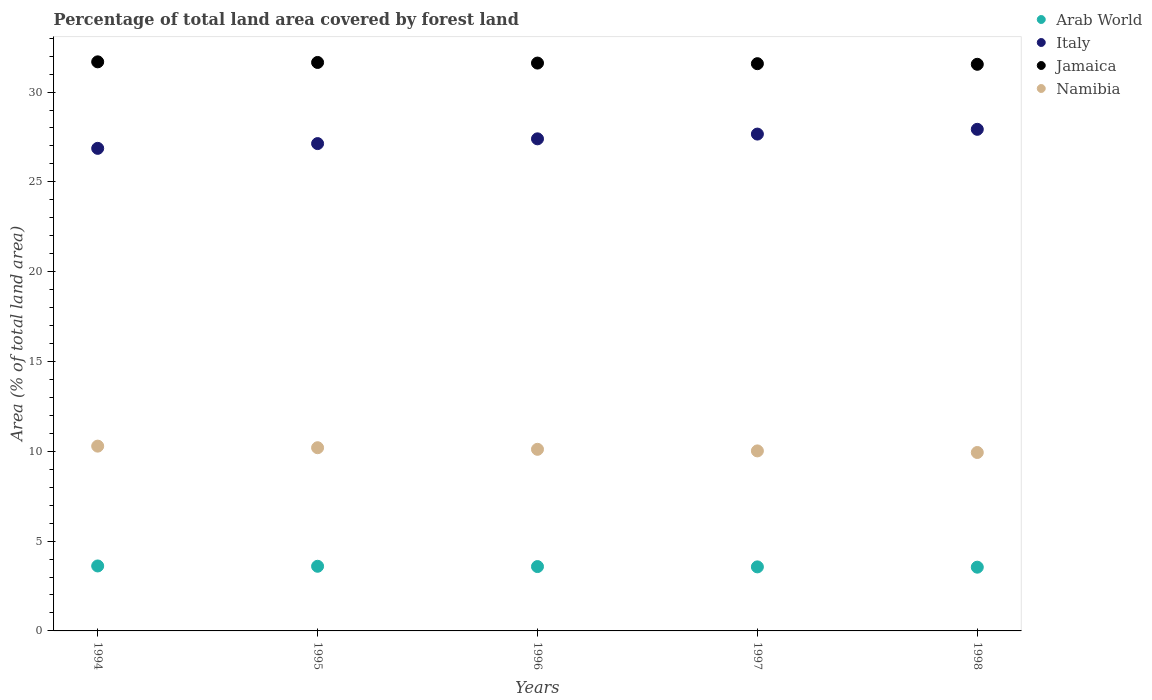How many different coloured dotlines are there?
Provide a succinct answer. 4. What is the percentage of forest land in Jamaica in 1998?
Give a very brief answer. 31.55. Across all years, what is the maximum percentage of forest land in Italy?
Provide a short and direct response. 27.93. Across all years, what is the minimum percentage of forest land in Arab World?
Your answer should be very brief. 3.55. In which year was the percentage of forest land in Italy minimum?
Your response must be concise. 1994. What is the total percentage of forest land in Arab World in the graph?
Give a very brief answer. 17.91. What is the difference between the percentage of forest land in Arab World in 1996 and that in 1998?
Provide a succinct answer. 0.03. What is the difference between the percentage of forest land in Arab World in 1994 and the percentage of forest land in Italy in 1995?
Give a very brief answer. -23.51. What is the average percentage of forest land in Namibia per year?
Provide a succinct answer. 10.11. In the year 1998, what is the difference between the percentage of forest land in Italy and percentage of forest land in Namibia?
Provide a succinct answer. 17.99. What is the ratio of the percentage of forest land in Arab World in 1995 to that in 1996?
Keep it short and to the point. 1. Is the difference between the percentage of forest land in Italy in 1994 and 1995 greater than the difference between the percentage of forest land in Namibia in 1994 and 1995?
Your response must be concise. No. What is the difference between the highest and the second highest percentage of forest land in Namibia?
Your answer should be compact. 0.09. What is the difference between the highest and the lowest percentage of forest land in Namibia?
Keep it short and to the point. 0.35. Is the sum of the percentage of forest land in Italy in 1995 and 1997 greater than the maximum percentage of forest land in Namibia across all years?
Give a very brief answer. Yes. Is the percentage of forest land in Namibia strictly greater than the percentage of forest land in Italy over the years?
Offer a very short reply. No. How many dotlines are there?
Your answer should be compact. 4. How many years are there in the graph?
Offer a terse response. 5. Does the graph contain grids?
Your answer should be compact. No. Where does the legend appear in the graph?
Make the answer very short. Top right. How many legend labels are there?
Give a very brief answer. 4. How are the legend labels stacked?
Keep it short and to the point. Vertical. What is the title of the graph?
Offer a terse response. Percentage of total land area covered by forest land. Does "Middle income" appear as one of the legend labels in the graph?
Your answer should be very brief. No. What is the label or title of the Y-axis?
Ensure brevity in your answer.  Area (% of total land area). What is the Area (% of total land area) of Arab World in 1994?
Your answer should be compact. 3.62. What is the Area (% of total land area) in Italy in 1994?
Give a very brief answer. 26.87. What is the Area (% of total land area) in Jamaica in 1994?
Provide a succinct answer. 31.68. What is the Area (% of total land area) in Namibia in 1994?
Your response must be concise. 10.29. What is the Area (% of total land area) in Arab World in 1995?
Offer a very short reply. 3.6. What is the Area (% of total land area) of Italy in 1995?
Provide a short and direct response. 27.13. What is the Area (% of total land area) in Jamaica in 1995?
Give a very brief answer. 31.65. What is the Area (% of total land area) of Namibia in 1995?
Keep it short and to the point. 10.2. What is the Area (% of total land area) of Arab World in 1996?
Your answer should be very brief. 3.58. What is the Area (% of total land area) of Italy in 1996?
Make the answer very short. 27.4. What is the Area (% of total land area) in Jamaica in 1996?
Provide a short and direct response. 31.61. What is the Area (% of total land area) of Namibia in 1996?
Your response must be concise. 10.11. What is the Area (% of total land area) in Arab World in 1997?
Make the answer very short. 3.57. What is the Area (% of total land area) of Italy in 1997?
Offer a very short reply. 27.66. What is the Area (% of total land area) of Jamaica in 1997?
Make the answer very short. 31.58. What is the Area (% of total land area) of Namibia in 1997?
Offer a very short reply. 10.02. What is the Area (% of total land area) of Arab World in 1998?
Provide a succinct answer. 3.55. What is the Area (% of total land area) in Italy in 1998?
Your answer should be very brief. 27.93. What is the Area (% of total land area) in Jamaica in 1998?
Offer a very short reply. 31.55. What is the Area (% of total land area) in Namibia in 1998?
Your response must be concise. 9.93. Across all years, what is the maximum Area (% of total land area) in Arab World?
Provide a succinct answer. 3.62. Across all years, what is the maximum Area (% of total land area) of Italy?
Your answer should be very brief. 27.93. Across all years, what is the maximum Area (% of total land area) of Jamaica?
Provide a succinct answer. 31.68. Across all years, what is the maximum Area (% of total land area) in Namibia?
Your answer should be compact. 10.29. Across all years, what is the minimum Area (% of total land area) of Arab World?
Provide a succinct answer. 3.55. Across all years, what is the minimum Area (% of total land area) of Italy?
Make the answer very short. 26.87. Across all years, what is the minimum Area (% of total land area) of Jamaica?
Keep it short and to the point. 31.55. Across all years, what is the minimum Area (% of total land area) of Namibia?
Your response must be concise. 9.93. What is the total Area (% of total land area) of Arab World in the graph?
Provide a short and direct response. 17.91. What is the total Area (% of total land area) in Italy in the graph?
Your answer should be very brief. 136.98. What is the total Area (% of total land area) of Jamaica in the graph?
Offer a terse response. 158.07. What is the total Area (% of total land area) of Namibia in the graph?
Your response must be concise. 50.55. What is the difference between the Area (% of total land area) of Arab World in 1994 and that in 1995?
Give a very brief answer. 0.02. What is the difference between the Area (% of total land area) in Italy in 1994 and that in 1995?
Provide a succinct answer. -0.26. What is the difference between the Area (% of total land area) in Jamaica in 1994 and that in 1995?
Give a very brief answer. 0.03. What is the difference between the Area (% of total land area) of Namibia in 1994 and that in 1995?
Provide a short and direct response. 0.09. What is the difference between the Area (% of total land area) of Arab World in 1994 and that in 1996?
Offer a very short reply. 0.03. What is the difference between the Area (% of total land area) in Italy in 1994 and that in 1996?
Ensure brevity in your answer.  -0.53. What is the difference between the Area (% of total land area) of Jamaica in 1994 and that in 1996?
Provide a short and direct response. 0.07. What is the difference between the Area (% of total land area) of Namibia in 1994 and that in 1996?
Provide a short and direct response. 0.18. What is the difference between the Area (% of total land area) in Arab World in 1994 and that in 1997?
Give a very brief answer. 0.05. What is the difference between the Area (% of total land area) of Italy in 1994 and that in 1997?
Your answer should be compact. -0.79. What is the difference between the Area (% of total land area) in Jamaica in 1994 and that in 1997?
Offer a very short reply. 0.1. What is the difference between the Area (% of total land area) in Namibia in 1994 and that in 1997?
Give a very brief answer. 0.27. What is the difference between the Area (% of total land area) of Arab World in 1994 and that in 1998?
Keep it short and to the point. 0.07. What is the difference between the Area (% of total land area) in Italy in 1994 and that in 1998?
Offer a very short reply. -1.06. What is the difference between the Area (% of total land area) of Jamaica in 1994 and that in 1998?
Give a very brief answer. 0.14. What is the difference between the Area (% of total land area) in Namibia in 1994 and that in 1998?
Make the answer very short. 0.35. What is the difference between the Area (% of total land area) in Arab World in 1995 and that in 1996?
Provide a short and direct response. 0.02. What is the difference between the Area (% of total land area) of Italy in 1995 and that in 1996?
Give a very brief answer. -0.26. What is the difference between the Area (% of total land area) of Jamaica in 1995 and that in 1996?
Provide a succinct answer. 0.03. What is the difference between the Area (% of total land area) in Namibia in 1995 and that in 1996?
Make the answer very short. 0.09. What is the difference between the Area (% of total land area) of Arab World in 1995 and that in 1997?
Ensure brevity in your answer.  0.03. What is the difference between the Area (% of total land area) in Italy in 1995 and that in 1997?
Your response must be concise. -0.53. What is the difference between the Area (% of total land area) of Jamaica in 1995 and that in 1997?
Ensure brevity in your answer.  0.07. What is the difference between the Area (% of total land area) of Namibia in 1995 and that in 1997?
Offer a very short reply. 0.18. What is the difference between the Area (% of total land area) of Arab World in 1995 and that in 1998?
Offer a very short reply. 0.05. What is the difference between the Area (% of total land area) of Italy in 1995 and that in 1998?
Your response must be concise. -0.79. What is the difference between the Area (% of total land area) in Jamaica in 1995 and that in 1998?
Your response must be concise. 0.1. What is the difference between the Area (% of total land area) in Namibia in 1995 and that in 1998?
Your response must be concise. 0.27. What is the difference between the Area (% of total land area) in Arab World in 1996 and that in 1997?
Your answer should be very brief. 0.02. What is the difference between the Area (% of total land area) of Italy in 1996 and that in 1997?
Make the answer very short. -0.26. What is the difference between the Area (% of total land area) in Jamaica in 1996 and that in 1997?
Your response must be concise. 0.03. What is the difference between the Area (% of total land area) of Namibia in 1996 and that in 1997?
Offer a very short reply. 0.09. What is the difference between the Area (% of total land area) in Arab World in 1996 and that in 1998?
Provide a short and direct response. 0.03. What is the difference between the Area (% of total land area) in Italy in 1996 and that in 1998?
Your response must be concise. -0.53. What is the difference between the Area (% of total land area) in Jamaica in 1996 and that in 1998?
Give a very brief answer. 0.07. What is the difference between the Area (% of total land area) in Namibia in 1996 and that in 1998?
Ensure brevity in your answer.  0.18. What is the difference between the Area (% of total land area) of Arab World in 1997 and that in 1998?
Offer a terse response. 0.02. What is the difference between the Area (% of total land area) of Italy in 1997 and that in 1998?
Provide a succinct answer. -0.26. What is the difference between the Area (% of total land area) of Jamaica in 1997 and that in 1998?
Give a very brief answer. 0.03. What is the difference between the Area (% of total land area) in Namibia in 1997 and that in 1998?
Your answer should be compact. 0.09. What is the difference between the Area (% of total land area) of Arab World in 1994 and the Area (% of total land area) of Italy in 1995?
Provide a short and direct response. -23.51. What is the difference between the Area (% of total land area) in Arab World in 1994 and the Area (% of total land area) in Jamaica in 1995?
Your answer should be very brief. -28.03. What is the difference between the Area (% of total land area) in Arab World in 1994 and the Area (% of total land area) in Namibia in 1995?
Keep it short and to the point. -6.58. What is the difference between the Area (% of total land area) of Italy in 1994 and the Area (% of total land area) of Jamaica in 1995?
Provide a short and direct response. -4.78. What is the difference between the Area (% of total land area) in Italy in 1994 and the Area (% of total land area) in Namibia in 1995?
Make the answer very short. 16.67. What is the difference between the Area (% of total land area) in Jamaica in 1994 and the Area (% of total land area) in Namibia in 1995?
Provide a short and direct response. 21.48. What is the difference between the Area (% of total land area) in Arab World in 1994 and the Area (% of total land area) in Italy in 1996?
Provide a short and direct response. -23.78. What is the difference between the Area (% of total land area) in Arab World in 1994 and the Area (% of total land area) in Jamaica in 1996?
Give a very brief answer. -28. What is the difference between the Area (% of total land area) of Arab World in 1994 and the Area (% of total land area) of Namibia in 1996?
Provide a short and direct response. -6.49. What is the difference between the Area (% of total land area) in Italy in 1994 and the Area (% of total land area) in Jamaica in 1996?
Your response must be concise. -4.75. What is the difference between the Area (% of total land area) of Italy in 1994 and the Area (% of total land area) of Namibia in 1996?
Provide a short and direct response. 16.76. What is the difference between the Area (% of total land area) of Jamaica in 1994 and the Area (% of total land area) of Namibia in 1996?
Offer a very short reply. 21.57. What is the difference between the Area (% of total land area) of Arab World in 1994 and the Area (% of total land area) of Italy in 1997?
Offer a very short reply. -24.04. What is the difference between the Area (% of total land area) in Arab World in 1994 and the Area (% of total land area) in Jamaica in 1997?
Offer a terse response. -27.96. What is the difference between the Area (% of total land area) in Arab World in 1994 and the Area (% of total land area) in Namibia in 1997?
Provide a short and direct response. -6.41. What is the difference between the Area (% of total land area) of Italy in 1994 and the Area (% of total land area) of Jamaica in 1997?
Provide a succinct answer. -4.71. What is the difference between the Area (% of total land area) of Italy in 1994 and the Area (% of total land area) of Namibia in 1997?
Keep it short and to the point. 16.84. What is the difference between the Area (% of total land area) in Jamaica in 1994 and the Area (% of total land area) in Namibia in 1997?
Provide a succinct answer. 21.66. What is the difference between the Area (% of total land area) of Arab World in 1994 and the Area (% of total land area) of Italy in 1998?
Make the answer very short. -24.31. What is the difference between the Area (% of total land area) of Arab World in 1994 and the Area (% of total land area) of Jamaica in 1998?
Make the answer very short. -27.93. What is the difference between the Area (% of total land area) of Arab World in 1994 and the Area (% of total land area) of Namibia in 1998?
Ensure brevity in your answer.  -6.32. What is the difference between the Area (% of total land area) of Italy in 1994 and the Area (% of total land area) of Jamaica in 1998?
Give a very brief answer. -4.68. What is the difference between the Area (% of total land area) of Italy in 1994 and the Area (% of total land area) of Namibia in 1998?
Make the answer very short. 16.93. What is the difference between the Area (% of total land area) of Jamaica in 1994 and the Area (% of total land area) of Namibia in 1998?
Provide a succinct answer. 21.75. What is the difference between the Area (% of total land area) of Arab World in 1995 and the Area (% of total land area) of Italy in 1996?
Offer a very short reply. -23.8. What is the difference between the Area (% of total land area) of Arab World in 1995 and the Area (% of total land area) of Jamaica in 1996?
Provide a short and direct response. -28.01. What is the difference between the Area (% of total land area) in Arab World in 1995 and the Area (% of total land area) in Namibia in 1996?
Your response must be concise. -6.51. What is the difference between the Area (% of total land area) of Italy in 1995 and the Area (% of total land area) of Jamaica in 1996?
Keep it short and to the point. -4.48. What is the difference between the Area (% of total land area) in Italy in 1995 and the Area (% of total land area) in Namibia in 1996?
Ensure brevity in your answer.  17.02. What is the difference between the Area (% of total land area) of Jamaica in 1995 and the Area (% of total land area) of Namibia in 1996?
Your answer should be very brief. 21.54. What is the difference between the Area (% of total land area) of Arab World in 1995 and the Area (% of total land area) of Italy in 1997?
Your response must be concise. -24.06. What is the difference between the Area (% of total land area) of Arab World in 1995 and the Area (% of total land area) of Jamaica in 1997?
Provide a short and direct response. -27.98. What is the difference between the Area (% of total land area) in Arab World in 1995 and the Area (% of total land area) in Namibia in 1997?
Your answer should be very brief. -6.42. What is the difference between the Area (% of total land area) in Italy in 1995 and the Area (% of total land area) in Jamaica in 1997?
Offer a terse response. -4.45. What is the difference between the Area (% of total land area) in Italy in 1995 and the Area (% of total land area) in Namibia in 1997?
Your answer should be very brief. 17.11. What is the difference between the Area (% of total land area) of Jamaica in 1995 and the Area (% of total land area) of Namibia in 1997?
Your response must be concise. 21.63. What is the difference between the Area (% of total land area) of Arab World in 1995 and the Area (% of total land area) of Italy in 1998?
Offer a very short reply. -24.33. What is the difference between the Area (% of total land area) of Arab World in 1995 and the Area (% of total land area) of Jamaica in 1998?
Ensure brevity in your answer.  -27.95. What is the difference between the Area (% of total land area) in Arab World in 1995 and the Area (% of total land area) in Namibia in 1998?
Ensure brevity in your answer.  -6.33. What is the difference between the Area (% of total land area) of Italy in 1995 and the Area (% of total land area) of Jamaica in 1998?
Ensure brevity in your answer.  -4.41. What is the difference between the Area (% of total land area) of Italy in 1995 and the Area (% of total land area) of Namibia in 1998?
Make the answer very short. 17.2. What is the difference between the Area (% of total land area) of Jamaica in 1995 and the Area (% of total land area) of Namibia in 1998?
Give a very brief answer. 21.71. What is the difference between the Area (% of total land area) of Arab World in 1996 and the Area (% of total land area) of Italy in 1997?
Offer a very short reply. -24.08. What is the difference between the Area (% of total land area) in Arab World in 1996 and the Area (% of total land area) in Jamaica in 1997?
Make the answer very short. -28. What is the difference between the Area (% of total land area) of Arab World in 1996 and the Area (% of total land area) of Namibia in 1997?
Make the answer very short. -6.44. What is the difference between the Area (% of total land area) in Italy in 1996 and the Area (% of total land area) in Jamaica in 1997?
Provide a succinct answer. -4.18. What is the difference between the Area (% of total land area) in Italy in 1996 and the Area (% of total land area) in Namibia in 1997?
Make the answer very short. 17.37. What is the difference between the Area (% of total land area) in Jamaica in 1996 and the Area (% of total land area) in Namibia in 1997?
Offer a terse response. 21.59. What is the difference between the Area (% of total land area) of Arab World in 1996 and the Area (% of total land area) of Italy in 1998?
Give a very brief answer. -24.34. What is the difference between the Area (% of total land area) in Arab World in 1996 and the Area (% of total land area) in Jamaica in 1998?
Your answer should be compact. -27.96. What is the difference between the Area (% of total land area) in Arab World in 1996 and the Area (% of total land area) in Namibia in 1998?
Offer a very short reply. -6.35. What is the difference between the Area (% of total land area) in Italy in 1996 and the Area (% of total land area) in Jamaica in 1998?
Make the answer very short. -4.15. What is the difference between the Area (% of total land area) in Italy in 1996 and the Area (% of total land area) in Namibia in 1998?
Provide a succinct answer. 17.46. What is the difference between the Area (% of total land area) of Jamaica in 1996 and the Area (% of total land area) of Namibia in 1998?
Offer a very short reply. 21.68. What is the difference between the Area (% of total land area) in Arab World in 1997 and the Area (% of total land area) in Italy in 1998?
Your answer should be compact. -24.36. What is the difference between the Area (% of total land area) in Arab World in 1997 and the Area (% of total land area) in Jamaica in 1998?
Your answer should be very brief. -27.98. What is the difference between the Area (% of total land area) in Arab World in 1997 and the Area (% of total land area) in Namibia in 1998?
Your answer should be compact. -6.37. What is the difference between the Area (% of total land area) of Italy in 1997 and the Area (% of total land area) of Jamaica in 1998?
Provide a succinct answer. -3.88. What is the difference between the Area (% of total land area) in Italy in 1997 and the Area (% of total land area) in Namibia in 1998?
Offer a very short reply. 17.73. What is the difference between the Area (% of total land area) of Jamaica in 1997 and the Area (% of total land area) of Namibia in 1998?
Your answer should be compact. 21.65. What is the average Area (% of total land area) of Arab World per year?
Provide a succinct answer. 3.58. What is the average Area (% of total land area) of Italy per year?
Give a very brief answer. 27.4. What is the average Area (% of total land area) of Jamaica per year?
Make the answer very short. 31.61. What is the average Area (% of total land area) of Namibia per year?
Your answer should be very brief. 10.11. In the year 1994, what is the difference between the Area (% of total land area) of Arab World and Area (% of total land area) of Italy?
Keep it short and to the point. -23.25. In the year 1994, what is the difference between the Area (% of total land area) of Arab World and Area (% of total land area) of Jamaica?
Give a very brief answer. -28.07. In the year 1994, what is the difference between the Area (% of total land area) of Arab World and Area (% of total land area) of Namibia?
Provide a succinct answer. -6.67. In the year 1994, what is the difference between the Area (% of total land area) in Italy and Area (% of total land area) in Jamaica?
Make the answer very short. -4.82. In the year 1994, what is the difference between the Area (% of total land area) of Italy and Area (% of total land area) of Namibia?
Give a very brief answer. 16.58. In the year 1994, what is the difference between the Area (% of total land area) in Jamaica and Area (% of total land area) in Namibia?
Give a very brief answer. 21.39. In the year 1995, what is the difference between the Area (% of total land area) in Arab World and Area (% of total land area) in Italy?
Provide a short and direct response. -23.53. In the year 1995, what is the difference between the Area (% of total land area) in Arab World and Area (% of total land area) in Jamaica?
Provide a short and direct response. -28.05. In the year 1995, what is the difference between the Area (% of total land area) in Italy and Area (% of total land area) in Jamaica?
Ensure brevity in your answer.  -4.52. In the year 1995, what is the difference between the Area (% of total land area) of Italy and Area (% of total land area) of Namibia?
Offer a very short reply. 16.93. In the year 1995, what is the difference between the Area (% of total land area) of Jamaica and Area (% of total land area) of Namibia?
Your answer should be compact. 21.45. In the year 1996, what is the difference between the Area (% of total land area) in Arab World and Area (% of total land area) in Italy?
Keep it short and to the point. -23.81. In the year 1996, what is the difference between the Area (% of total land area) of Arab World and Area (% of total land area) of Jamaica?
Provide a short and direct response. -28.03. In the year 1996, what is the difference between the Area (% of total land area) in Arab World and Area (% of total land area) in Namibia?
Ensure brevity in your answer.  -6.53. In the year 1996, what is the difference between the Area (% of total land area) in Italy and Area (% of total land area) in Jamaica?
Offer a very short reply. -4.22. In the year 1996, what is the difference between the Area (% of total land area) in Italy and Area (% of total land area) in Namibia?
Make the answer very short. 17.29. In the year 1996, what is the difference between the Area (% of total land area) in Jamaica and Area (% of total land area) in Namibia?
Offer a terse response. 21.5. In the year 1997, what is the difference between the Area (% of total land area) of Arab World and Area (% of total land area) of Italy?
Keep it short and to the point. -24.1. In the year 1997, what is the difference between the Area (% of total land area) in Arab World and Area (% of total land area) in Jamaica?
Provide a succinct answer. -28.01. In the year 1997, what is the difference between the Area (% of total land area) in Arab World and Area (% of total land area) in Namibia?
Your answer should be compact. -6.46. In the year 1997, what is the difference between the Area (% of total land area) in Italy and Area (% of total land area) in Jamaica?
Offer a very short reply. -3.92. In the year 1997, what is the difference between the Area (% of total land area) in Italy and Area (% of total land area) in Namibia?
Provide a succinct answer. 17.64. In the year 1997, what is the difference between the Area (% of total land area) in Jamaica and Area (% of total land area) in Namibia?
Your answer should be compact. 21.56. In the year 1998, what is the difference between the Area (% of total land area) in Arab World and Area (% of total land area) in Italy?
Your answer should be very brief. -24.38. In the year 1998, what is the difference between the Area (% of total land area) in Arab World and Area (% of total land area) in Jamaica?
Keep it short and to the point. -28. In the year 1998, what is the difference between the Area (% of total land area) of Arab World and Area (% of total land area) of Namibia?
Keep it short and to the point. -6.38. In the year 1998, what is the difference between the Area (% of total land area) in Italy and Area (% of total land area) in Jamaica?
Give a very brief answer. -3.62. In the year 1998, what is the difference between the Area (% of total land area) of Italy and Area (% of total land area) of Namibia?
Your response must be concise. 17.99. In the year 1998, what is the difference between the Area (% of total land area) in Jamaica and Area (% of total land area) in Namibia?
Provide a short and direct response. 21.61. What is the ratio of the Area (% of total land area) in Italy in 1994 to that in 1995?
Your answer should be compact. 0.99. What is the ratio of the Area (% of total land area) in Jamaica in 1994 to that in 1995?
Provide a succinct answer. 1. What is the ratio of the Area (% of total land area) in Namibia in 1994 to that in 1995?
Your answer should be very brief. 1.01. What is the ratio of the Area (% of total land area) in Arab World in 1994 to that in 1996?
Your answer should be compact. 1.01. What is the ratio of the Area (% of total land area) of Italy in 1994 to that in 1996?
Make the answer very short. 0.98. What is the ratio of the Area (% of total land area) of Namibia in 1994 to that in 1996?
Make the answer very short. 1.02. What is the ratio of the Area (% of total land area) in Arab World in 1994 to that in 1997?
Offer a very short reply. 1.01. What is the ratio of the Area (% of total land area) of Italy in 1994 to that in 1997?
Keep it short and to the point. 0.97. What is the ratio of the Area (% of total land area) of Jamaica in 1994 to that in 1997?
Ensure brevity in your answer.  1. What is the ratio of the Area (% of total land area) of Namibia in 1994 to that in 1997?
Provide a succinct answer. 1.03. What is the ratio of the Area (% of total land area) in Arab World in 1994 to that in 1998?
Your answer should be compact. 1.02. What is the ratio of the Area (% of total land area) of Italy in 1994 to that in 1998?
Give a very brief answer. 0.96. What is the ratio of the Area (% of total land area) of Jamaica in 1994 to that in 1998?
Give a very brief answer. 1. What is the ratio of the Area (% of total land area) of Namibia in 1994 to that in 1998?
Provide a succinct answer. 1.04. What is the ratio of the Area (% of total land area) in Arab World in 1995 to that in 1996?
Your answer should be compact. 1. What is the ratio of the Area (% of total land area) of Italy in 1995 to that in 1996?
Keep it short and to the point. 0.99. What is the ratio of the Area (% of total land area) of Jamaica in 1995 to that in 1996?
Provide a succinct answer. 1. What is the ratio of the Area (% of total land area) of Namibia in 1995 to that in 1996?
Make the answer very short. 1.01. What is the ratio of the Area (% of total land area) of Arab World in 1995 to that in 1997?
Your answer should be compact. 1.01. What is the ratio of the Area (% of total land area) in Italy in 1995 to that in 1997?
Your answer should be very brief. 0.98. What is the ratio of the Area (% of total land area) in Namibia in 1995 to that in 1997?
Your response must be concise. 1.02. What is the ratio of the Area (% of total land area) in Arab World in 1995 to that in 1998?
Your answer should be very brief. 1.01. What is the ratio of the Area (% of total land area) of Italy in 1995 to that in 1998?
Keep it short and to the point. 0.97. What is the ratio of the Area (% of total land area) of Namibia in 1995 to that in 1998?
Provide a short and direct response. 1.03. What is the ratio of the Area (% of total land area) in Namibia in 1996 to that in 1997?
Your response must be concise. 1.01. What is the ratio of the Area (% of total land area) in Arab World in 1996 to that in 1998?
Provide a succinct answer. 1.01. What is the ratio of the Area (% of total land area) in Italy in 1996 to that in 1998?
Keep it short and to the point. 0.98. What is the ratio of the Area (% of total land area) in Namibia in 1996 to that in 1998?
Keep it short and to the point. 1.02. What is the ratio of the Area (% of total land area) of Italy in 1997 to that in 1998?
Provide a succinct answer. 0.99. What is the ratio of the Area (% of total land area) of Jamaica in 1997 to that in 1998?
Keep it short and to the point. 1. What is the ratio of the Area (% of total land area) in Namibia in 1997 to that in 1998?
Give a very brief answer. 1.01. What is the difference between the highest and the second highest Area (% of total land area) of Arab World?
Your response must be concise. 0.02. What is the difference between the highest and the second highest Area (% of total land area) of Italy?
Your answer should be compact. 0.26. What is the difference between the highest and the second highest Area (% of total land area) of Jamaica?
Offer a terse response. 0.03. What is the difference between the highest and the second highest Area (% of total land area) in Namibia?
Provide a succinct answer. 0.09. What is the difference between the highest and the lowest Area (% of total land area) of Arab World?
Keep it short and to the point. 0.07. What is the difference between the highest and the lowest Area (% of total land area) in Italy?
Your answer should be very brief. 1.06. What is the difference between the highest and the lowest Area (% of total land area) in Jamaica?
Your answer should be compact. 0.14. What is the difference between the highest and the lowest Area (% of total land area) of Namibia?
Make the answer very short. 0.35. 